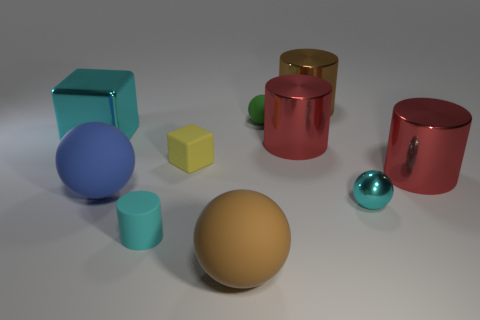There is a metal object that is on the left side of the rubber sphere that is left of the small cyan matte cylinder; is there a large brown shiny cylinder right of it?
Keep it short and to the point. Yes. Does the big brown ball have the same material as the brown object that is on the right side of the large brown ball?
Offer a very short reply. No. There is a big matte thing left of the brown object in front of the cyan cylinder; what is its color?
Offer a very short reply. Blue. Are there any metallic things of the same color as the tiny shiny sphere?
Your answer should be compact. Yes. There is a shiny cylinder that is to the right of the small sphere in front of the block that is on the left side of the cyan matte object; what size is it?
Your answer should be very brief. Large. Does the yellow object have the same shape as the cyan thing that is behind the small shiny sphere?
Your response must be concise. Yes. How many other things are there of the same size as the blue object?
Your response must be concise. 5. What size is the shiny object on the left side of the yellow matte thing?
Your answer should be compact. Large. How many large red cylinders are the same material as the large cube?
Give a very brief answer. 2. There is a large cyan metal object behind the cyan cylinder; does it have the same shape as the blue thing?
Your response must be concise. No. 